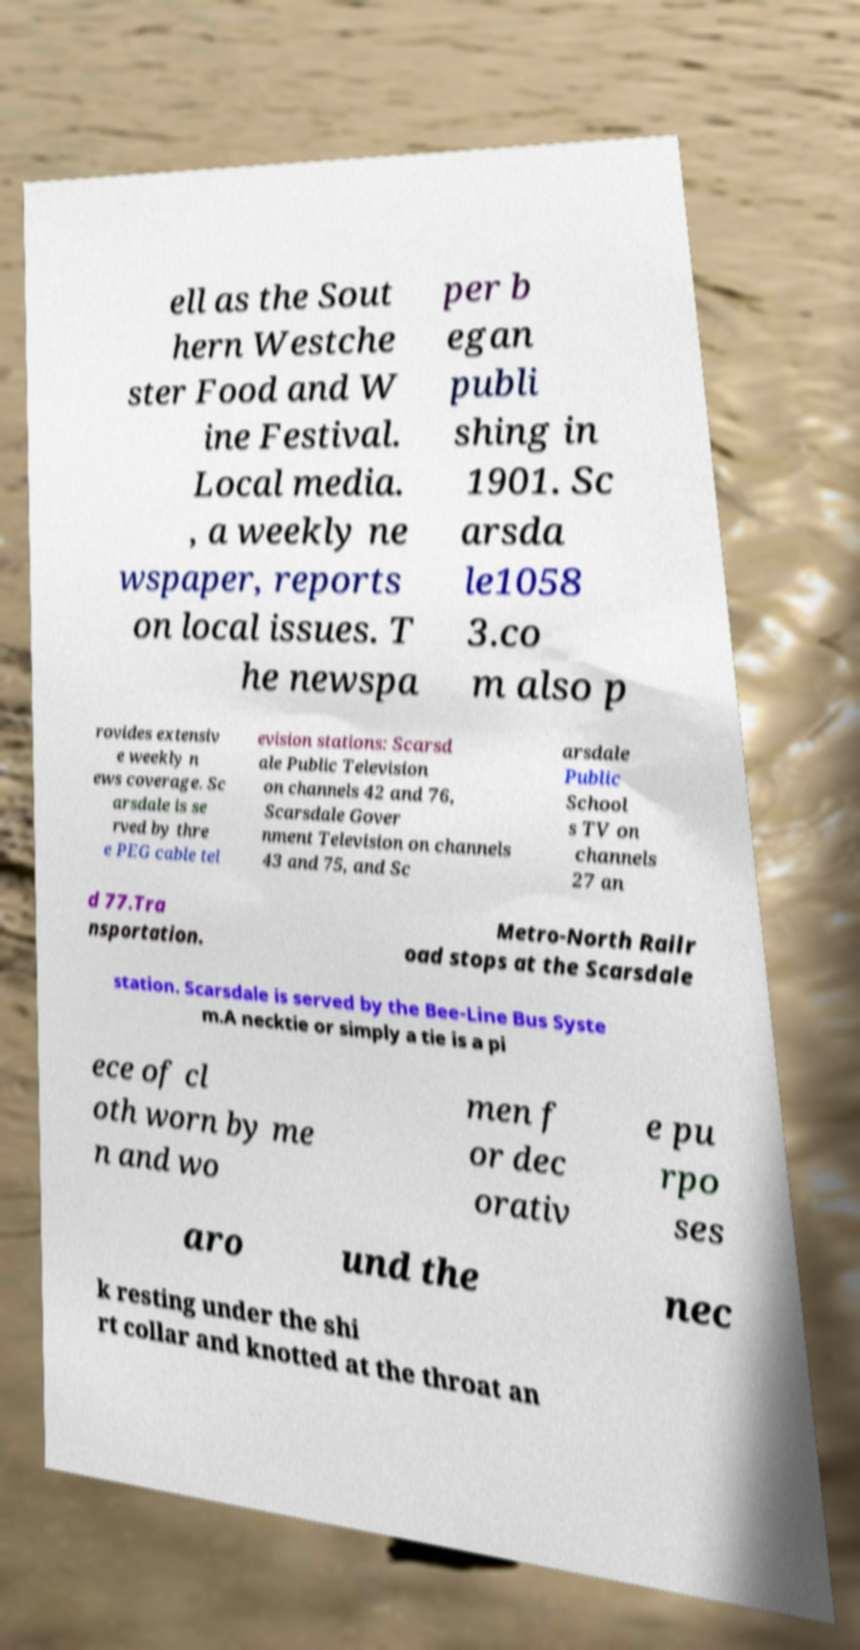Can you accurately transcribe the text from the provided image for me? ell as the Sout hern Westche ster Food and W ine Festival. Local media. , a weekly ne wspaper, reports on local issues. T he newspa per b egan publi shing in 1901. Sc arsda le1058 3.co m also p rovides extensiv e weekly n ews coverage. Sc arsdale is se rved by thre e PEG cable tel evision stations: Scarsd ale Public Television on channels 42 and 76, Scarsdale Gover nment Television on channels 43 and 75, and Sc arsdale Public School s TV on channels 27 an d 77.Tra nsportation. Metro-North Railr oad stops at the Scarsdale station. Scarsdale is served by the Bee-Line Bus Syste m.A necktie or simply a tie is a pi ece of cl oth worn by me n and wo men f or dec orativ e pu rpo ses aro und the nec k resting under the shi rt collar and knotted at the throat an 